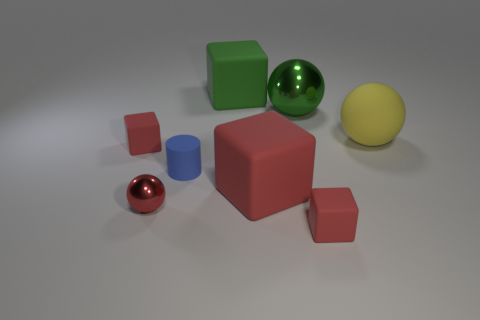Subtract all red cubes. How many were subtracted if there are1red cubes left? 2 Subtract all purple spheres. How many red blocks are left? 3 Add 1 balls. How many objects exist? 9 Subtract all purple cubes. Subtract all brown spheres. How many cubes are left? 4 Subtract all cylinders. How many objects are left? 7 Subtract all tiny yellow matte cylinders. Subtract all tiny metal things. How many objects are left? 7 Add 1 large green metallic spheres. How many large green metallic spheres are left? 2 Add 4 gray metallic cylinders. How many gray metallic cylinders exist? 4 Subtract 0 red cylinders. How many objects are left? 8 